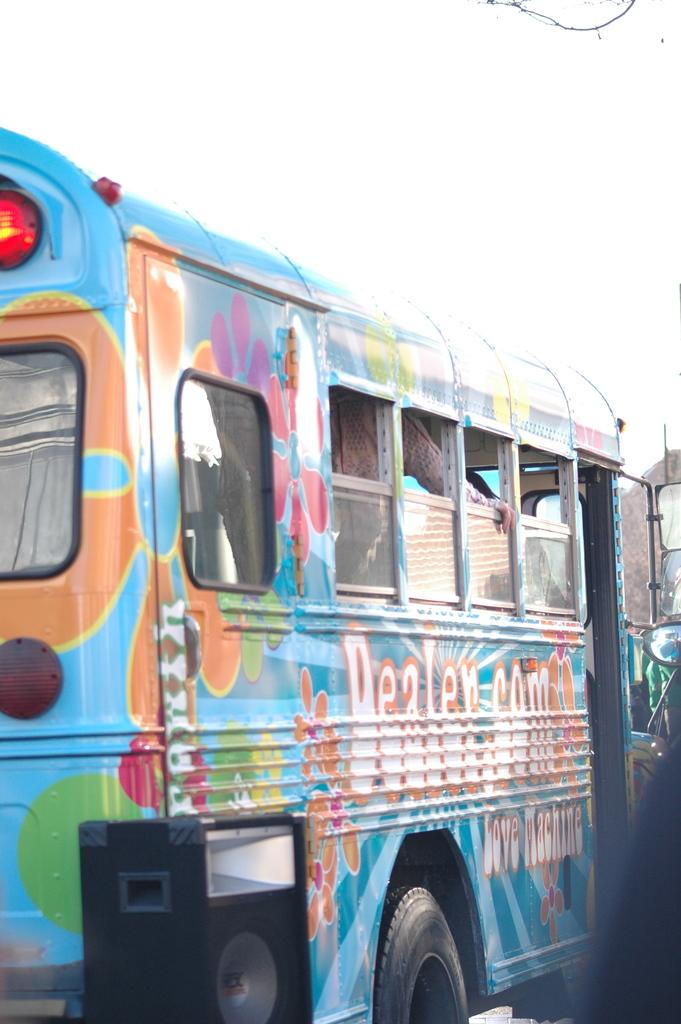What is the main subject in the image? There is a vehicle in the image. What else can be seen in the image besides the vehicle? There is a sound box and the sky visible in the image. Is there anyone inside the vehicle? Yes, there is a person in the vehicle. What is the person wearing? The person is wearing clothes. How many cats are sitting on the person's lap in the image? There are no cats present in the image. What type of flowers can be seen growing near the vehicle in the image? There are no flowers visible in the image. 